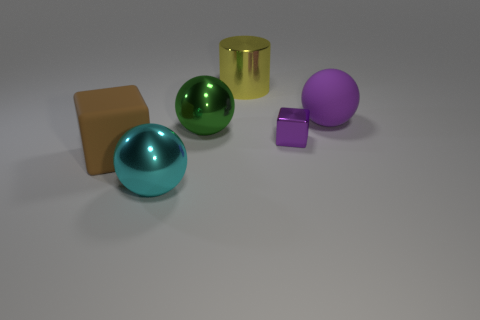Subtract all big metallic spheres. How many spheres are left? 1 Add 1 big green metal balls. How many objects exist? 7 Subtract all purple spheres. How many spheres are left? 2 Subtract all cubes. How many objects are left? 4 Subtract 1 cylinders. How many cylinders are left? 0 Subtract all brown cubes. Subtract all brown spheres. How many cubes are left? 1 Subtract all shiny cylinders. Subtract all shiny blocks. How many objects are left? 4 Add 6 metal objects. How many metal objects are left? 10 Add 4 big yellow rubber blocks. How many big yellow rubber blocks exist? 4 Subtract 0 red cylinders. How many objects are left? 6 